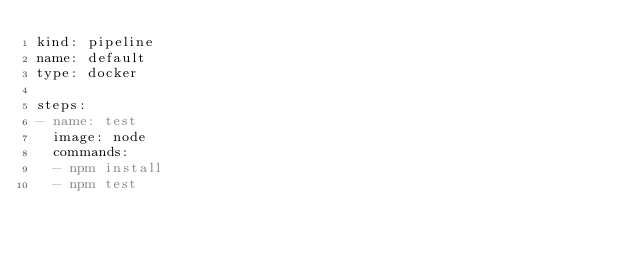Convert code to text. <code><loc_0><loc_0><loc_500><loc_500><_YAML_>kind: pipeline
name: default
type: docker

steps:
- name: test
  image: node
  commands:
  - npm install
  - npm test
</code> 